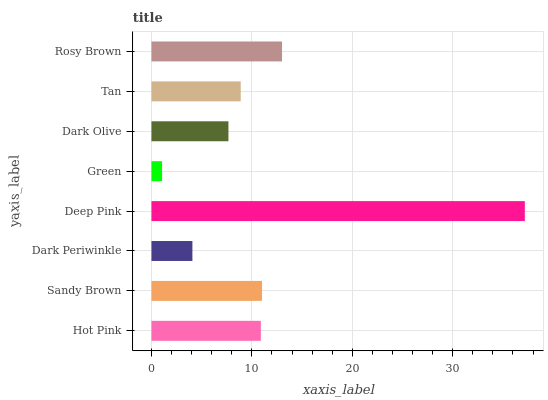Is Green the minimum?
Answer yes or no. Yes. Is Deep Pink the maximum?
Answer yes or no. Yes. Is Sandy Brown the minimum?
Answer yes or no. No. Is Sandy Brown the maximum?
Answer yes or no. No. Is Sandy Brown greater than Hot Pink?
Answer yes or no. Yes. Is Hot Pink less than Sandy Brown?
Answer yes or no. Yes. Is Hot Pink greater than Sandy Brown?
Answer yes or no. No. Is Sandy Brown less than Hot Pink?
Answer yes or no. No. Is Hot Pink the high median?
Answer yes or no. Yes. Is Tan the low median?
Answer yes or no. Yes. Is Tan the high median?
Answer yes or no. No. Is Rosy Brown the low median?
Answer yes or no. No. 